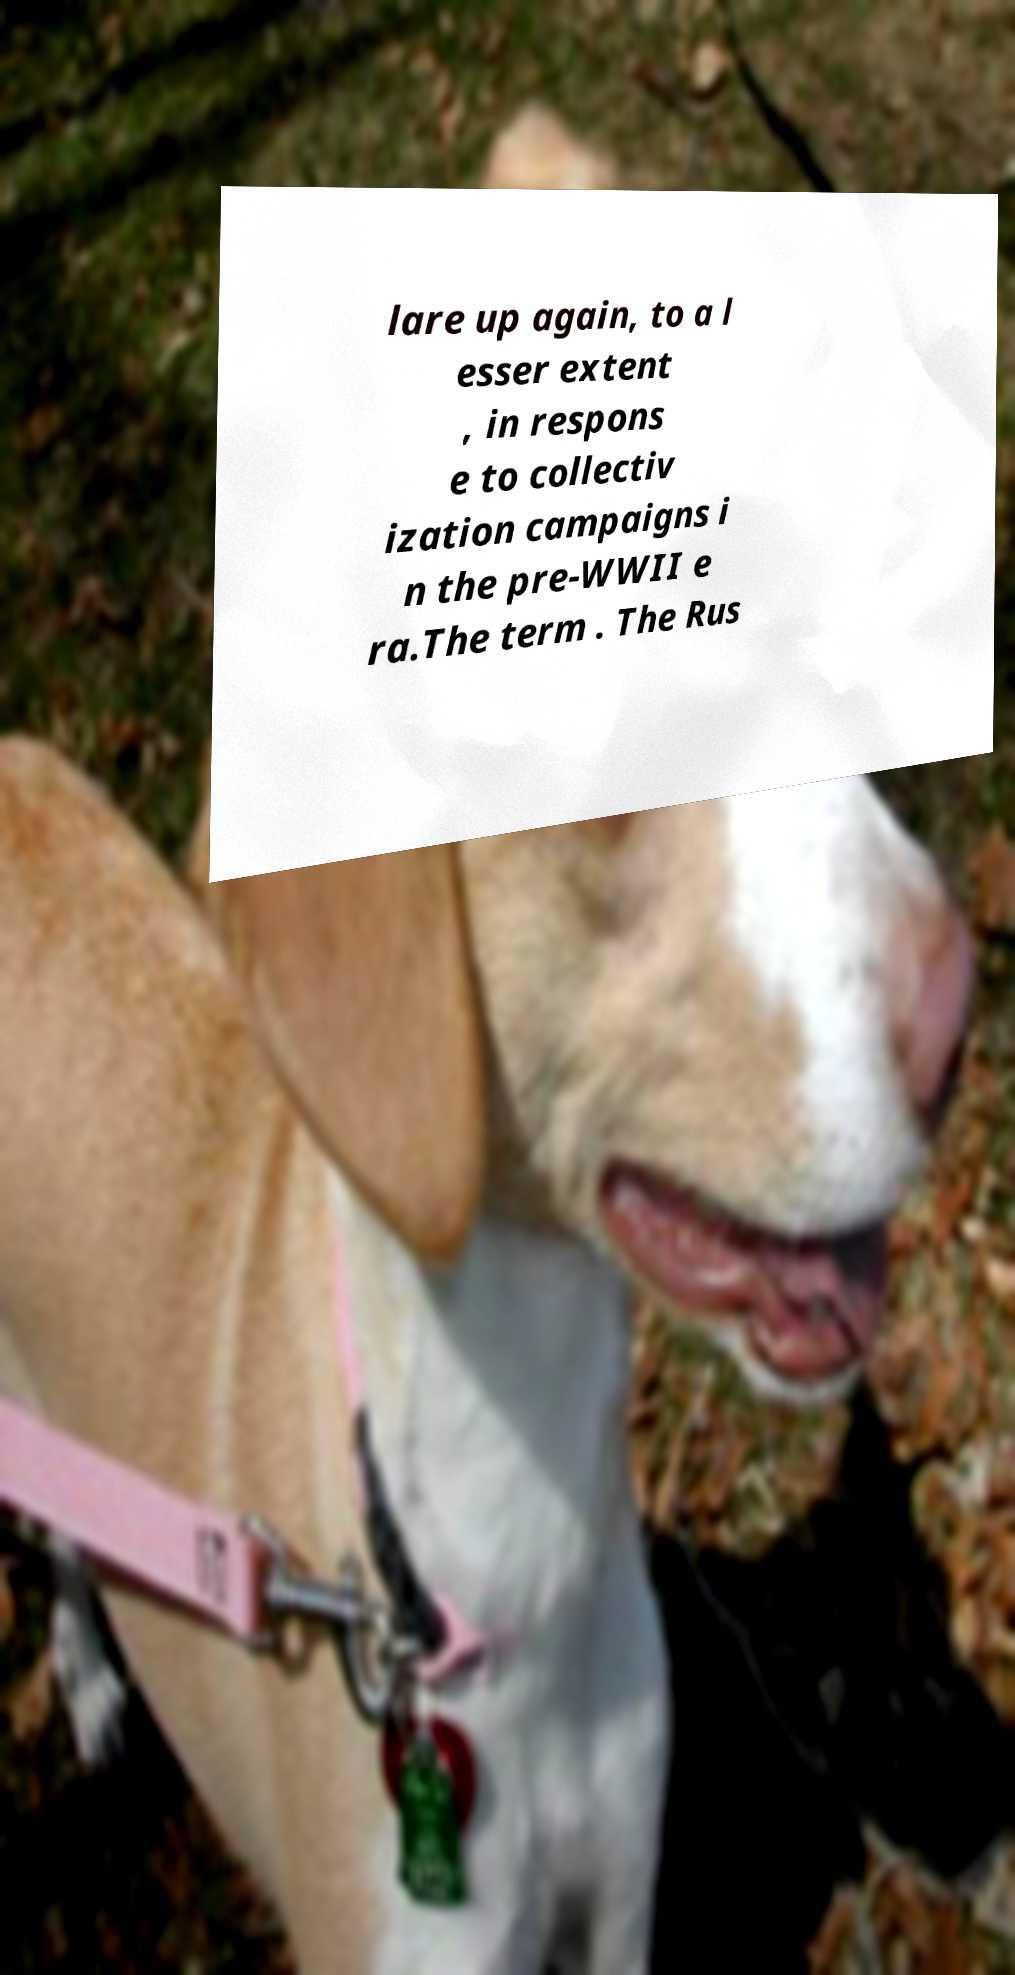For documentation purposes, I need the text within this image transcribed. Could you provide that? lare up again, to a l esser extent , in respons e to collectiv ization campaigns i n the pre-WWII e ra.The term . The Rus 